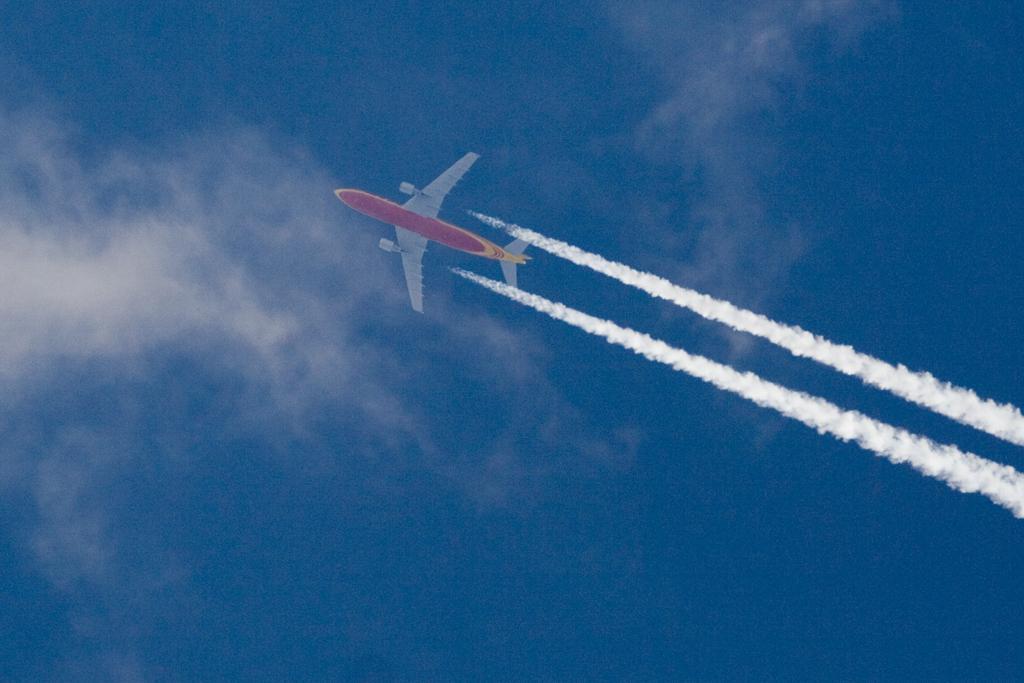How would you summarize this image in a sentence or two? In this picture there is an aircraft in the sky. On the right side of the image there is smoke. At the top there is sky and there are clouds. 